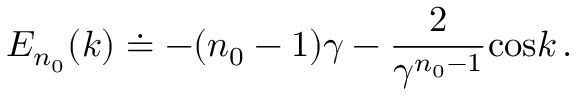<formula> <loc_0><loc_0><loc_500><loc_500>E _ { n _ { 0 } } ( k ) \doteq - ( n _ { 0 } - 1 ) \gamma - { \frac { 2 } { \gamma ^ { n _ { 0 } - 1 } } } \cos k \, .</formula> 